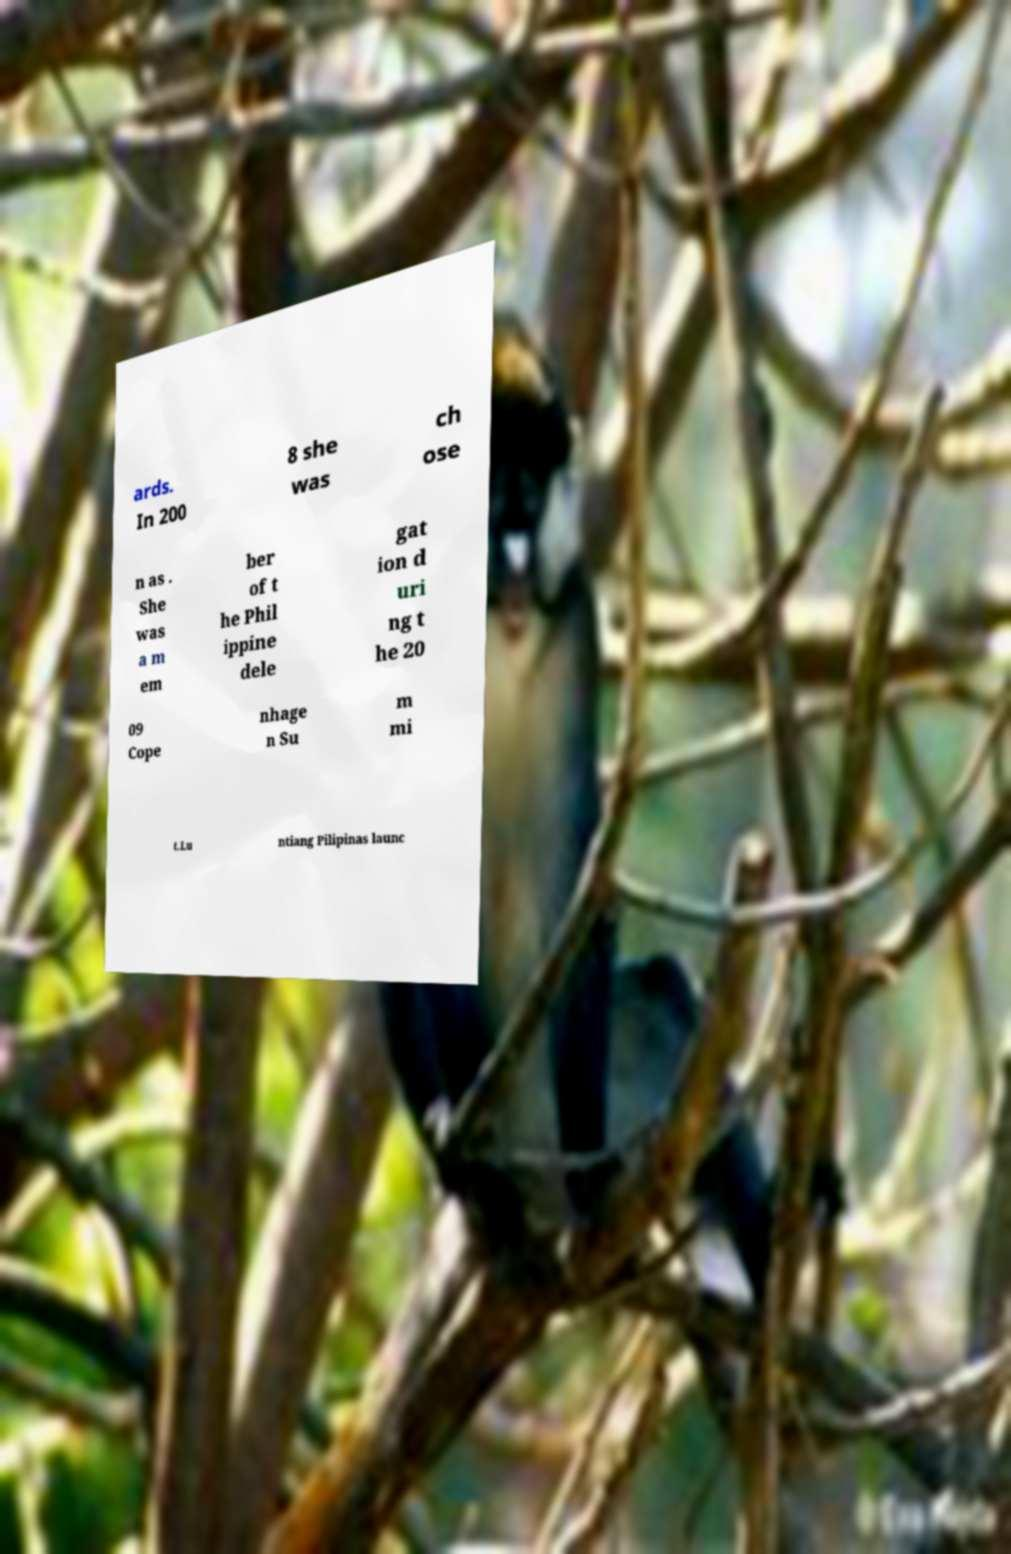Can you accurately transcribe the text from the provided image for me? ards. In 200 8 she was ch ose n as . She was a m em ber of t he Phil ippine dele gat ion d uri ng t he 20 09 Cope nhage n Su m mi t.Lu ntiang Pilipinas launc 